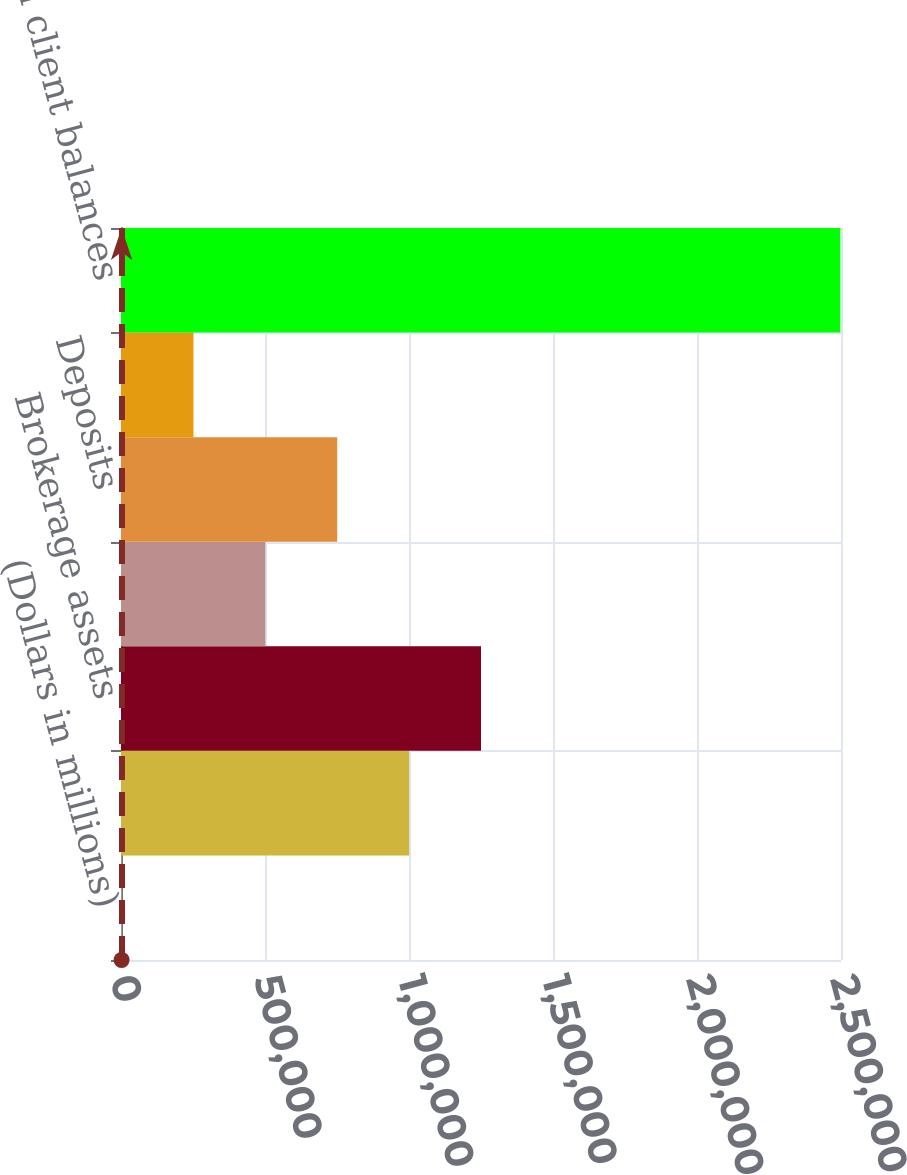Convert chart. <chart><loc_0><loc_0><loc_500><loc_500><bar_chart><fcel>(Dollars in millions)<fcel>Assets under management<fcel>Brokerage assets<fcel>Assets in custody<fcel>Deposits<fcel>Loans and leases (1)<fcel>Total client balances<nl><fcel>2014<fcel>1.00041e+06<fcel>1.25001e+06<fcel>501211<fcel>750809<fcel>251612<fcel>2.498e+06<nl></chart> 